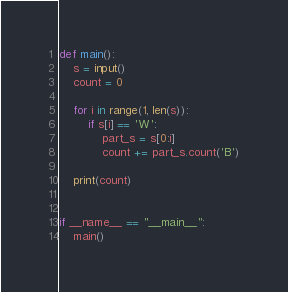Convert code to text. <code><loc_0><loc_0><loc_500><loc_500><_Python_>def main():
    s = input()
    count = 0

    for i in range(1, len(s)):
        if s[i] == 'W':
            part_s = s[0:i]
            count += part_s.count('B')

    print(count)


if __name__ == "__main__":
    main()
</code> 